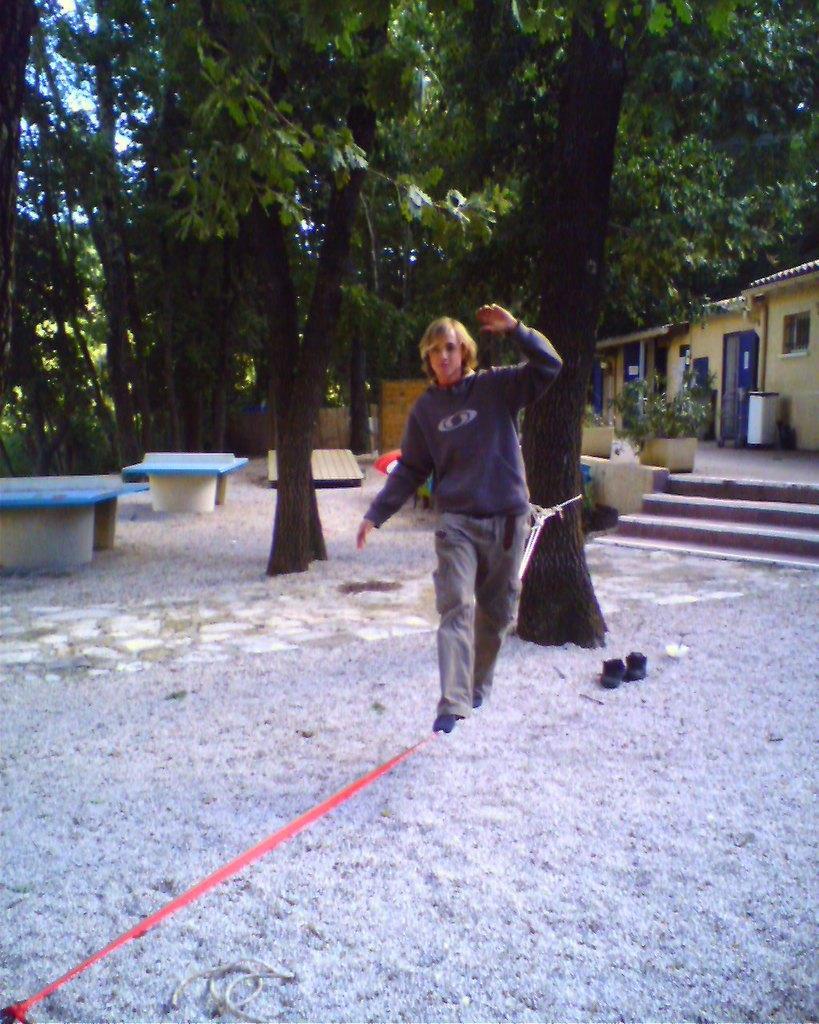In one or two sentences, can you explain what this image depicts? In this image I can see the person is standing. I can see few trees, buildings, flowerpots, stairs, benches, few objects and the sky. 